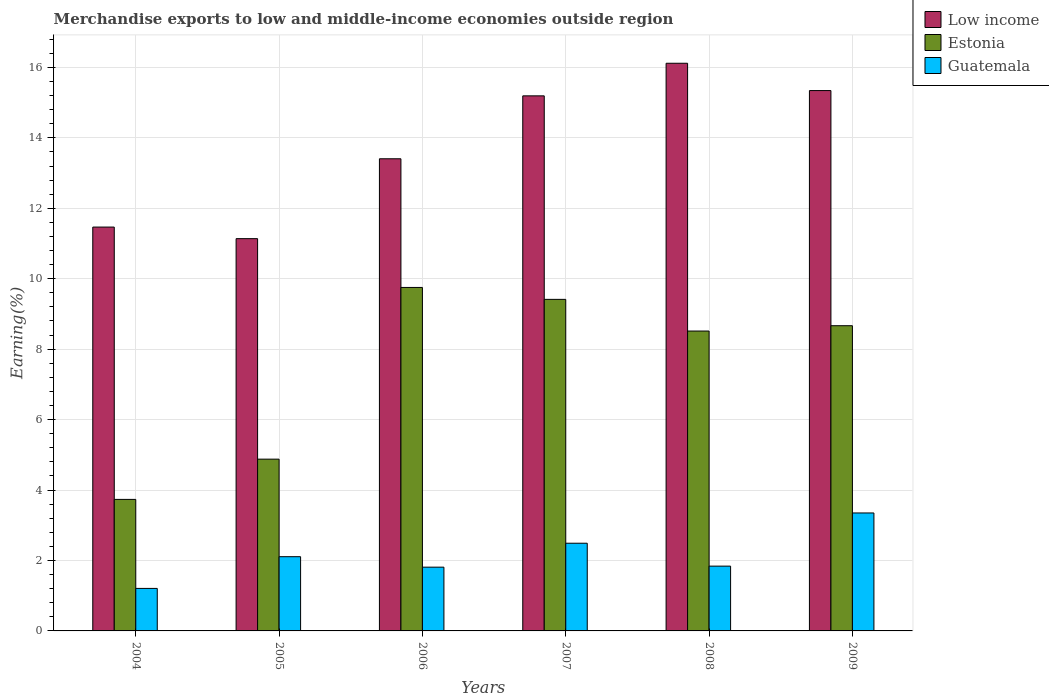Are the number of bars per tick equal to the number of legend labels?
Ensure brevity in your answer.  Yes. What is the label of the 5th group of bars from the left?
Keep it short and to the point. 2008. What is the percentage of amount earned from merchandise exports in Estonia in 2007?
Offer a terse response. 9.41. Across all years, what is the maximum percentage of amount earned from merchandise exports in Low income?
Offer a very short reply. 16.12. Across all years, what is the minimum percentage of amount earned from merchandise exports in Estonia?
Offer a terse response. 3.73. In which year was the percentage of amount earned from merchandise exports in Guatemala maximum?
Offer a very short reply. 2009. In which year was the percentage of amount earned from merchandise exports in Estonia minimum?
Give a very brief answer. 2004. What is the total percentage of amount earned from merchandise exports in Guatemala in the graph?
Make the answer very short. 12.8. What is the difference between the percentage of amount earned from merchandise exports in Low income in 2004 and that in 2009?
Ensure brevity in your answer.  -3.88. What is the difference between the percentage of amount earned from merchandise exports in Estonia in 2005 and the percentage of amount earned from merchandise exports in Guatemala in 2009?
Your answer should be very brief. 1.53. What is the average percentage of amount earned from merchandise exports in Estonia per year?
Your response must be concise. 7.49. In the year 2006, what is the difference between the percentage of amount earned from merchandise exports in Low income and percentage of amount earned from merchandise exports in Estonia?
Make the answer very short. 3.65. What is the ratio of the percentage of amount earned from merchandise exports in Low income in 2004 to that in 2007?
Your answer should be very brief. 0.75. Is the percentage of amount earned from merchandise exports in Guatemala in 2007 less than that in 2008?
Ensure brevity in your answer.  No. Is the difference between the percentage of amount earned from merchandise exports in Low income in 2005 and 2006 greater than the difference between the percentage of amount earned from merchandise exports in Estonia in 2005 and 2006?
Give a very brief answer. Yes. What is the difference between the highest and the second highest percentage of amount earned from merchandise exports in Estonia?
Keep it short and to the point. 0.34. What is the difference between the highest and the lowest percentage of amount earned from merchandise exports in Guatemala?
Keep it short and to the point. 2.14. In how many years, is the percentage of amount earned from merchandise exports in Estonia greater than the average percentage of amount earned from merchandise exports in Estonia taken over all years?
Keep it short and to the point. 4. Is the sum of the percentage of amount earned from merchandise exports in Guatemala in 2004 and 2008 greater than the maximum percentage of amount earned from merchandise exports in Low income across all years?
Your answer should be compact. No. What does the 2nd bar from the left in 2006 represents?
Your answer should be very brief. Estonia. What does the 1st bar from the right in 2007 represents?
Provide a short and direct response. Guatemala. Is it the case that in every year, the sum of the percentage of amount earned from merchandise exports in Estonia and percentage of amount earned from merchandise exports in Guatemala is greater than the percentage of amount earned from merchandise exports in Low income?
Your response must be concise. No. Are all the bars in the graph horizontal?
Ensure brevity in your answer.  No. What is the difference between two consecutive major ticks on the Y-axis?
Provide a short and direct response. 2. Where does the legend appear in the graph?
Your answer should be compact. Top right. How many legend labels are there?
Ensure brevity in your answer.  3. How are the legend labels stacked?
Offer a very short reply. Vertical. What is the title of the graph?
Ensure brevity in your answer.  Merchandise exports to low and middle-income economies outside region. What is the label or title of the X-axis?
Your response must be concise. Years. What is the label or title of the Y-axis?
Your response must be concise. Earning(%). What is the Earning(%) in Low income in 2004?
Offer a very short reply. 11.47. What is the Earning(%) in Estonia in 2004?
Your answer should be very brief. 3.73. What is the Earning(%) of Guatemala in 2004?
Offer a very short reply. 1.21. What is the Earning(%) of Low income in 2005?
Offer a very short reply. 11.14. What is the Earning(%) in Estonia in 2005?
Ensure brevity in your answer.  4.88. What is the Earning(%) in Guatemala in 2005?
Your response must be concise. 2.11. What is the Earning(%) of Low income in 2006?
Offer a very short reply. 13.41. What is the Earning(%) of Estonia in 2006?
Keep it short and to the point. 9.75. What is the Earning(%) of Guatemala in 2006?
Give a very brief answer. 1.81. What is the Earning(%) of Low income in 2007?
Your response must be concise. 15.19. What is the Earning(%) in Estonia in 2007?
Give a very brief answer. 9.41. What is the Earning(%) of Guatemala in 2007?
Give a very brief answer. 2.49. What is the Earning(%) in Low income in 2008?
Your answer should be very brief. 16.12. What is the Earning(%) in Estonia in 2008?
Ensure brevity in your answer.  8.51. What is the Earning(%) of Guatemala in 2008?
Provide a succinct answer. 1.84. What is the Earning(%) of Low income in 2009?
Ensure brevity in your answer.  15.34. What is the Earning(%) in Estonia in 2009?
Offer a terse response. 8.67. What is the Earning(%) in Guatemala in 2009?
Offer a very short reply. 3.35. Across all years, what is the maximum Earning(%) in Low income?
Offer a terse response. 16.12. Across all years, what is the maximum Earning(%) of Estonia?
Offer a very short reply. 9.75. Across all years, what is the maximum Earning(%) of Guatemala?
Your answer should be very brief. 3.35. Across all years, what is the minimum Earning(%) of Low income?
Give a very brief answer. 11.14. Across all years, what is the minimum Earning(%) in Estonia?
Offer a terse response. 3.73. Across all years, what is the minimum Earning(%) of Guatemala?
Offer a terse response. 1.21. What is the total Earning(%) of Low income in the graph?
Provide a succinct answer. 82.66. What is the total Earning(%) in Estonia in the graph?
Your answer should be compact. 44.96. What is the total Earning(%) in Guatemala in the graph?
Provide a succinct answer. 12.8. What is the difference between the Earning(%) in Low income in 2004 and that in 2005?
Offer a very short reply. 0.33. What is the difference between the Earning(%) of Estonia in 2004 and that in 2005?
Provide a succinct answer. -1.14. What is the difference between the Earning(%) in Guatemala in 2004 and that in 2005?
Offer a very short reply. -0.9. What is the difference between the Earning(%) of Low income in 2004 and that in 2006?
Ensure brevity in your answer.  -1.94. What is the difference between the Earning(%) in Estonia in 2004 and that in 2006?
Provide a short and direct response. -6.02. What is the difference between the Earning(%) of Guatemala in 2004 and that in 2006?
Offer a very short reply. -0.6. What is the difference between the Earning(%) of Low income in 2004 and that in 2007?
Your response must be concise. -3.73. What is the difference between the Earning(%) in Estonia in 2004 and that in 2007?
Offer a very short reply. -5.68. What is the difference between the Earning(%) of Guatemala in 2004 and that in 2007?
Your answer should be very brief. -1.28. What is the difference between the Earning(%) of Low income in 2004 and that in 2008?
Give a very brief answer. -4.65. What is the difference between the Earning(%) of Estonia in 2004 and that in 2008?
Keep it short and to the point. -4.78. What is the difference between the Earning(%) in Guatemala in 2004 and that in 2008?
Offer a terse response. -0.63. What is the difference between the Earning(%) in Low income in 2004 and that in 2009?
Offer a very short reply. -3.88. What is the difference between the Earning(%) in Estonia in 2004 and that in 2009?
Provide a succinct answer. -4.93. What is the difference between the Earning(%) in Guatemala in 2004 and that in 2009?
Provide a short and direct response. -2.14. What is the difference between the Earning(%) in Low income in 2005 and that in 2006?
Keep it short and to the point. -2.27. What is the difference between the Earning(%) in Estonia in 2005 and that in 2006?
Ensure brevity in your answer.  -4.88. What is the difference between the Earning(%) of Guatemala in 2005 and that in 2006?
Offer a very short reply. 0.3. What is the difference between the Earning(%) of Low income in 2005 and that in 2007?
Offer a terse response. -4.05. What is the difference between the Earning(%) in Estonia in 2005 and that in 2007?
Your answer should be very brief. -4.54. What is the difference between the Earning(%) in Guatemala in 2005 and that in 2007?
Your answer should be very brief. -0.38. What is the difference between the Earning(%) in Low income in 2005 and that in 2008?
Keep it short and to the point. -4.98. What is the difference between the Earning(%) in Estonia in 2005 and that in 2008?
Ensure brevity in your answer.  -3.64. What is the difference between the Earning(%) in Guatemala in 2005 and that in 2008?
Keep it short and to the point. 0.27. What is the difference between the Earning(%) of Low income in 2005 and that in 2009?
Make the answer very short. -4.2. What is the difference between the Earning(%) of Estonia in 2005 and that in 2009?
Provide a short and direct response. -3.79. What is the difference between the Earning(%) of Guatemala in 2005 and that in 2009?
Offer a terse response. -1.24. What is the difference between the Earning(%) of Low income in 2006 and that in 2007?
Keep it short and to the point. -1.79. What is the difference between the Earning(%) in Estonia in 2006 and that in 2007?
Keep it short and to the point. 0.34. What is the difference between the Earning(%) of Guatemala in 2006 and that in 2007?
Your response must be concise. -0.68. What is the difference between the Earning(%) in Low income in 2006 and that in 2008?
Keep it short and to the point. -2.71. What is the difference between the Earning(%) in Estonia in 2006 and that in 2008?
Your answer should be compact. 1.24. What is the difference between the Earning(%) in Guatemala in 2006 and that in 2008?
Offer a very short reply. -0.03. What is the difference between the Earning(%) of Low income in 2006 and that in 2009?
Your response must be concise. -1.94. What is the difference between the Earning(%) of Estonia in 2006 and that in 2009?
Provide a succinct answer. 1.09. What is the difference between the Earning(%) of Guatemala in 2006 and that in 2009?
Offer a terse response. -1.54. What is the difference between the Earning(%) in Low income in 2007 and that in 2008?
Provide a succinct answer. -0.93. What is the difference between the Earning(%) in Estonia in 2007 and that in 2008?
Your response must be concise. 0.9. What is the difference between the Earning(%) of Guatemala in 2007 and that in 2008?
Make the answer very short. 0.65. What is the difference between the Earning(%) of Low income in 2007 and that in 2009?
Provide a succinct answer. -0.15. What is the difference between the Earning(%) in Estonia in 2007 and that in 2009?
Provide a short and direct response. 0.75. What is the difference between the Earning(%) of Guatemala in 2007 and that in 2009?
Offer a terse response. -0.86. What is the difference between the Earning(%) of Low income in 2008 and that in 2009?
Provide a short and direct response. 0.78. What is the difference between the Earning(%) of Estonia in 2008 and that in 2009?
Your answer should be very brief. -0.15. What is the difference between the Earning(%) of Guatemala in 2008 and that in 2009?
Your answer should be compact. -1.51. What is the difference between the Earning(%) of Low income in 2004 and the Earning(%) of Estonia in 2005?
Offer a terse response. 6.59. What is the difference between the Earning(%) of Low income in 2004 and the Earning(%) of Guatemala in 2005?
Make the answer very short. 9.36. What is the difference between the Earning(%) of Estonia in 2004 and the Earning(%) of Guatemala in 2005?
Your response must be concise. 1.63. What is the difference between the Earning(%) in Low income in 2004 and the Earning(%) in Estonia in 2006?
Provide a succinct answer. 1.71. What is the difference between the Earning(%) of Low income in 2004 and the Earning(%) of Guatemala in 2006?
Your answer should be compact. 9.66. What is the difference between the Earning(%) of Estonia in 2004 and the Earning(%) of Guatemala in 2006?
Your answer should be very brief. 1.92. What is the difference between the Earning(%) in Low income in 2004 and the Earning(%) in Estonia in 2007?
Offer a very short reply. 2.05. What is the difference between the Earning(%) of Low income in 2004 and the Earning(%) of Guatemala in 2007?
Your response must be concise. 8.98. What is the difference between the Earning(%) in Estonia in 2004 and the Earning(%) in Guatemala in 2007?
Give a very brief answer. 1.24. What is the difference between the Earning(%) of Low income in 2004 and the Earning(%) of Estonia in 2008?
Keep it short and to the point. 2.95. What is the difference between the Earning(%) of Low income in 2004 and the Earning(%) of Guatemala in 2008?
Your response must be concise. 9.63. What is the difference between the Earning(%) in Estonia in 2004 and the Earning(%) in Guatemala in 2008?
Your answer should be very brief. 1.89. What is the difference between the Earning(%) of Low income in 2004 and the Earning(%) of Estonia in 2009?
Offer a very short reply. 2.8. What is the difference between the Earning(%) in Low income in 2004 and the Earning(%) in Guatemala in 2009?
Offer a very short reply. 8.12. What is the difference between the Earning(%) in Estonia in 2004 and the Earning(%) in Guatemala in 2009?
Provide a succinct answer. 0.39. What is the difference between the Earning(%) of Low income in 2005 and the Earning(%) of Estonia in 2006?
Make the answer very short. 1.39. What is the difference between the Earning(%) of Low income in 2005 and the Earning(%) of Guatemala in 2006?
Your response must be concise. 9.33. What is the difference between the Earning(%) of Estonia in 2005 and the Earning(%) of Guatemala in 2006?
Ensure brevity in your answer.  3.07. What is the difference between the Earning(%) in Low income in 2005 and the Earning(%) in Estonia in 2007?
Provide a short and direct response. 1.72. What is the difference between the Earning(%) of Low income in 2005 and the Earning(%) of Guatemala in 2007?
Offer a very short reply. 8.65. What is the difference between the Earning(%) in Estonia in 2005 and the Earning(%) in Guatemala in 2007?
Provide a short and direct response. 2.39. What is the difference between the Earning(%) in Low income in 2005 and the Earning(%) in Estonia in 2008?
Make the answer very short. 2.62. What is the difference between the Earning(%) in Low income in 2005 and the Earning(%) in Guatemala in 2008?
Give a very brief answer. 9.3. What is the difference between the Earning(%) of Estonia in 2005 and the Earning(%) of Guatemala in 2008?
Your response must be concise. 3.04. What is the difference between the Earning(%) in Low income in 2005 and the Earning(%) in Estonia in 2009?
Offer a terse response. 2.47. What is the difference between the Earning(%) in Low income in 2005 and the Earning(%) in Guatemala in 2009?
Provide a short and direct response. 7.79. What is the difference between the Earning(%) in Estonia in 2005 and the Earning(%) in Guatemala in 2009?
Give a very brief answer. 1.53. What is the difference between the Earning(%) in Low income in 2006 and the Earning(%) in Estonia in 2007?
Provide a succinct answer. 3.99. What is the difference between the Earning(%) of Low income in 2006 and the Earning(%) of Guatemala in 2007?
Provide a short and direct response. 10.92. What is the difference between the Earning(%) in Estonia in 2006 and the Earning(%) in Guatemala in 2007?
Give a very brief answer. 7.26. What is the difference between the Earning(%) of Low income in 2006 and the Earning(%) of Estonia in 2008?
Provide a short and direct response. 4.89. What is the difference between the Earning(%) in Low income in 2006 and the Earning(%) in Guatemala in 2008?
Offer a very short reply. 11.57. What is the difference between the Earning(%) of Estonia in 2006 and the Earning(%) of Guatemala in 2008?
Your response must be concise. 7.91. What is the difference between the Earning(%) in Low income in 2006 and the Earning(%) in Estonia in 2009?
Offer a very short reply. 4.74. What is the difference between the Earning(%) of Low income in 2006 and the Earning(%) of Guatemala in 2009?
Ensure brevity in your answer.  10.06. What is the difference between the Earning(%) of Estonia in 2006 and the Earning(%) of Guatemala in 2009?
Offer a very short reply. 6.4. What is the difference between the Earning(%) in Low income in 2007 and the Earning(%) in Estonia in 2008?
Offer a terse response. 6.68. What is the difference between the Earning(%) of Low income in 2007 and the Earning(%) of Guatemala in 2008?
Offer a very short reply. 13.35. What is the difference between the Earning(%) of Estonia in 2007 and the Earning(%) of Guatemala in 2008?
Make the answer very short. 7.57. What is the difference between the Earning(%) of Low income in 2007 and the Earning(%) of Estonia in 2009?
Ensure brevity in your answer.  6.53. What is the difference between the Earning(%) of Low income in 2007 and the Earning(%) of Guatemala in 2009?
Provide a succinct answer. 11.84. What is the difference between the Earning(%) of Estonia in 2007 and the Earning(%) of Guatemala in 2009?
Make the answer very short. 6.06. What is the difference between the Earning(%) in Low income in 2008 and the Earning(%) in Estonia in 2009?
Provide a short and direct response. 7.45. What is the difference between the Earning(%) of Low income in 2008 and the Earning(%) of Guatemala in 2009?
Make the answer very short. 12.77. What is the difference between the Earning(%) in Estonia in 2008 and the Earning(%) in Guatemala in 2009?
Give a very brief answer. 5.17. What is the average Earning(%) in Low income per year?
Keep it short and to the point. 13.78. What is the average Earning(%) of Estonia per year?
Your response must be concise. 7.49. What is the average Earning(%) of Guatemala per year?
Ensure brevity in your answer.  2.13. In the year 2004, what is the difference between the Earning(%) in Low income and Earning(%) in Estonia?
Offer a terse response. 7.73. In the year 2004, what is the difference between the Earning(%) of Low income and Earning(%) of Guatemala?
Keep it short and to the point. 10.26. In the year 2004, what is the difference between the Earning(%) in Estonia and Earning(%) in Guatemala?
Your answer should be very brief. 2.53. In the year 2005, what is the difference between the Earning(%) of Low income and Earning(%) of Estonia?
Make the answer very short. 6.26. In the year 2005, what is the difference between the Earning(%) of Low income and Earning(%) of Guatemala?
Offer a terse response. 9.03. In the year 2005, what is the difference between the Earning(%) of Estonia and Earning(%) of Guatemala?
Your answer should be very brief. 2.77. In the year 2006, what is the difference between the Earning(%) in Low income and Earning(%) in Estonia?
Give a very brief answer. 3.65. In the year 2006, what is the difference between the Earning(%) in Low income and Earning(%) in Guatemala?
Your response must be concise. 11.6. In the year 2006, what is the difference between the Earning(%) of Estonia and Earning(%) of Guatemala?
Your response must be concise. 7.94. In the year 2007, what is the difference between the Earning(%) in Low income and Earning(%) in Estonia?
Ensure brevity in your answer.  5.78. In the year 2007, what is the difference between the Earning(%) of Low income and Earning(%) of Guatemala?
Ensure brevity in your answer.  12.7. In the year 2007, what is the difference between the Earning(%) in Estonia and Earning(%) in Guatemala?
Provide a succinct answer. 6.92. In the year 2008, what is the difference between the Earning(%) in Low income and Earning(%) in Estonia?
Keep it short and to the point. 7.6. In the year 2008, what is the difference between the Earning(%) in Low income and Earning(%) in Guatemala?
Keep it short and to the point. 14.28. In the year 2008, what is the difference between the Earning(%) in Estonia and Earning(%) in Guatemala?
Your answer should be compact. 6.67. In the year 2009, what is the difference between the Earning(%) of Low income and Earning(%) of Estonia?
Provide a short and direct response. 6.68. In the year 2009, what is the difference between the Earning(%) in Low income and Earning(%) in Guatemala?
Ensure brevity in your answer.  11.99. In the year 2009, what is the difference between the Earning(%) in Estonia and Earning(%) in Guatemala?
Give a very brief answer. 5.32. What is the ratio of the Earning(%) in Low income in 2004 to that in 2005?
Offer a very short reply. 1.03. What is the ratio of the Earning(%) in Estonia in 2004 to that in 2005?
Offer a very short reply. 0.77. What is the ratio of the Earning(%) in Guatemala in 2004 to that in 2005?
Your answer should be very brief. 0.57. What is the ratio of the Earning(%) in Low income in 2004 to that in 2006?
Ensure brevity in your answer.  0.86. What is the ratio of the Earning(%) in Estonia in 2004 to that in 2006?
Offer a terse response. 0.38. What is the ratio of the Earning(%) of Guatemala in 2004 to that in 2006?
Ensure brevity in your answer.  0.67. What is the ratio of the Earning(%) of Low income in 2004 to that in 2007?
Make the answer very short. 0.75. What is the ratio of the Earning(%) of Estonia in 2004 to that in 2007?
Your answer should be compact. 0.4. What is the ratio of the Earning(%) in Guatemala in 2004 to that in 2007?
Give a very brief answer. 0.48. What is the ratio of the Earning(%) of Low income in 2004 to that in 2008?
Provide a short and direct response. 0.71. What is the ratio of the Earning(%) in Estonia in 2004 to that in 2008?
Provide a succinct answer. 0.44. What is the ratio of the Earning(%) of Guatemala in 2004 to that in 2008?
Provide a short and direct response. 0.66. What is the ratio of the Earning(%) of Low income in 2004 to that in 2009?
Give a very brief answer. 0.75. What is the ratio of the Earning(%) in Estonia in 2004 to that in 2009?
Ensure brevity in your answer.  0.43. What is the ratio of the Earning(%) of Guatemala in 2004 to that in 2009?
Make the answer very short. 0.36. What is the ratio of the Earning(%) of Low income in 2005 to that in 2006?
Offer a very short reply. 0.83. What is the ratio of the Earning(%) in Estonia in 2005 to that in 2006?
Your response must be concise. 0.5. What is the ratio of the Earning(%) of Guatemala in 2005 to that in 2006?
Your response must be concise. 1.16. What is the ratio of the Earning(%) in Low income in 2005 to that in 2007?
Offer a very short reply. 0.73. What is the ratio of the Earning(%) in Estonia in 2005 to that in 2007?
Offer a very short reply. 0.52. What is the ratio of the Earning(%) in Guatemala in 2005 to that in 2007?
Your answer should be compact. 0.85. What is the ratio of the Earning(%) of Low income in 2005 to that in 2008?
Keep it short and to the point. 0.69. What is the ratio of the Earning(%) of Estonia in 2005 to that in 2008?
Offer a very short reply. 0.57. What is the ratio of the Earning(%) of Guatemala in 2005 to that in 2008?
Offer a very short reply. 1.15. What is the ratio of the Earning(%) of Low income in 2005 to that in 2009?
Offer a terse response. 0.73. What is the ratio of the Earning(%) of Estonia in 2005 to that in 2009?
Provide a succinct answer. 0.56. What is the ratio of the Earning(%) in Guatemala in 2005 to that in 2009?
Provide a short and direct response. 0.63. What is the ratio of the Earning(%) in Low income in 2006 to that in 2007?
Provide a short and direct response. 0.88. What is the ratio of the Earning(%) in Estonia in 2006 to that in 2007?
Keep it short and to the point. 1.04. What is the ratio of the Earning(%) in Guatemala in 2006 to that in 2007?
Make the answer very short. 0.73. What is the ratio of the Earning(%) in Low income in 2006 to that in 2008?
Give a very brief answer. 0.83. What is the ratio of the Earning(%) in Estonia in 2006 to that in 2008?
Make the answer very short. 1.15. What is the ratio of the Earning(%) in Guatemala in 2006 to that in 2008?
Make the answer very short. 0.98. What is the ratio of the Earning(%) in Low income in 2006 to that in 2009?
Offer a very short reply. 0.87. What is the ratio of the Earning(%) in Estonia in 2006 to that in 2009?
Ensure brevity in your answer.  1.13. What is the ratio of the Earning(%) in Guatemala in 2006 to that in 2009?
Your answer should be very brief. 0.54. What is the ratio of the Earning(%) of Low income in 2007 to that in 2008?
Make the answer very short. 0.94. What is the ratio of the Earning(%) of Estonia in 2007 to that in 2008?
Give a very brief answer. 1.11. What is the ratio of the Earning(%) in Guatemala in 2007 to that in 2008?
Your answer should be very brief. 1.35. What is the ratio of the Earning(%) in Low income in 2007 to that in 2009?
Ensure brevity in your answer.  0.99. What is the ratio of the Earning(%) of Estonia in 2007 to that in 2009?
Provide a short and direct response. 1.09. What is the ratio of the Earning(%) in Guatemala in 2007 to that in 2009?
Offer a terse response. 0.74. What is the ratio of the Earning(%) of Low income in 2008 to that in 2009?
Offer a terse response. 1.05. What is the ratio of the Earning(%) in Estonia in 2008 to that in 2009?
Ensure brevity in your answer.  0.98. What is the ratio of the Earning(%) of Guatemala in 2008 to that in 2009?
Make the answer very short. 0.55. What is the difference between the highest and the second highest Earning(%) in Low income?
Give a very brief answer. 0.78. What is the difference between the highest and the second highest Earning(%) in Estonia?
Offer a terse response. 0.34. What is the difference between the highest and the second highest Earning(%) of Guatemala?
Provide a short and direct response. 0.86. What is the difference between the highest and the lowest Earning(%) of Low income?
Ensure brevity in your answer.  4.98. What is the difference between the highest and the lowest Earning(%) of Estonia?
Your response must be concise. 6.02. What is the difference between the highest and the lowest Earning(%) of Guatemala?
Give a very brief answer. 2.14. 